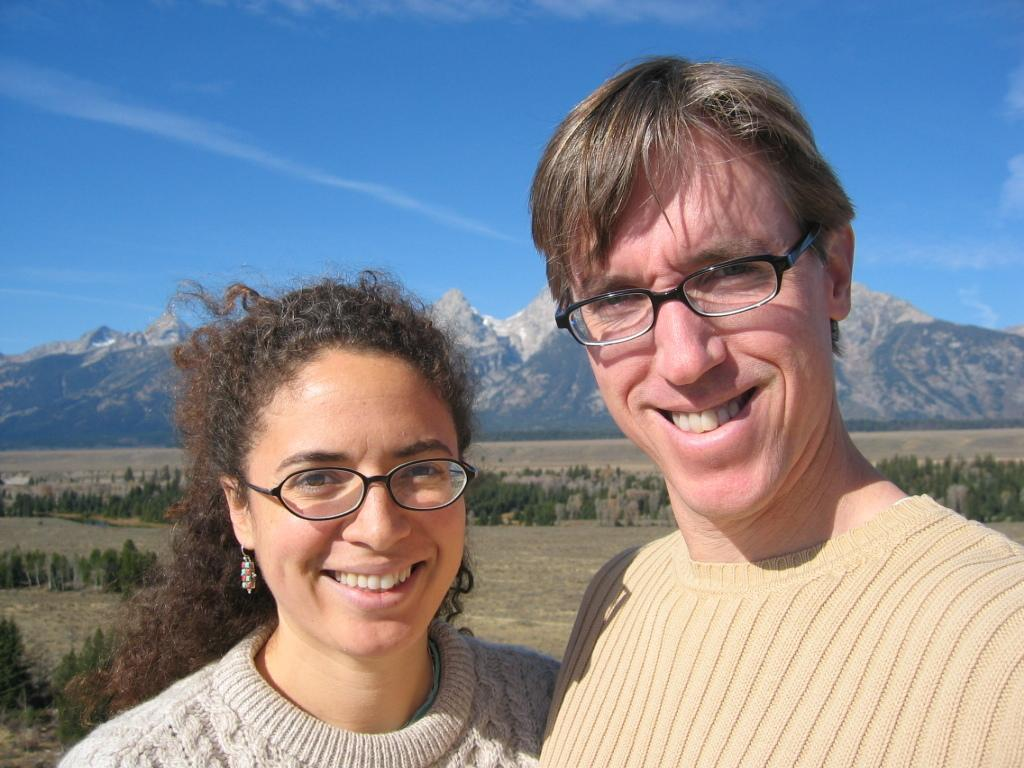Who or what can be seen in the front of the image? There are persons in the front of the image. What is the facial expression of the persons in the image? The persons are smiling. What type of natural scenery is visible in the background of the image? There are plants and mountains in the background of the image. What is visible in the sky at the top of the image? Clouds are visible in the sky at the top of the image. What type of twig is being used as a prop on the stage in the image? There is no stage or twig present in the image. What kind of paper is being used by the persons in the image? There is no paper visible in the image; the persons are simply smiling. 